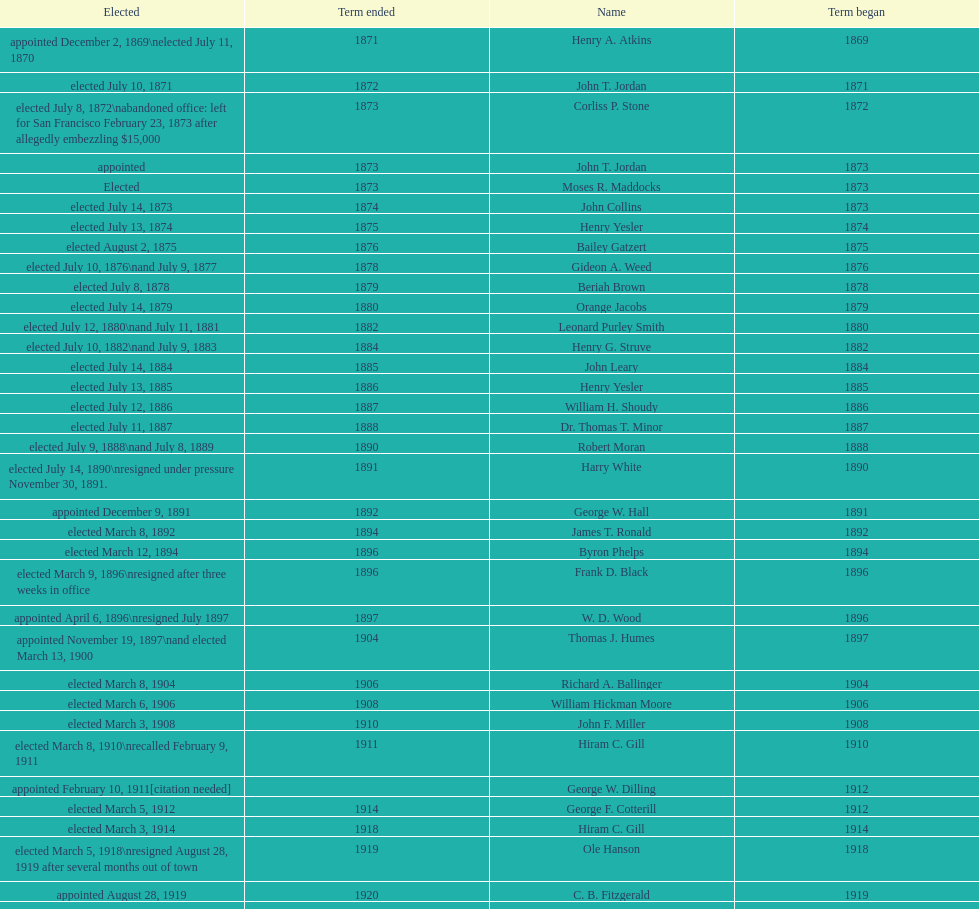What is the number of mayors with the first name of john? 6. 